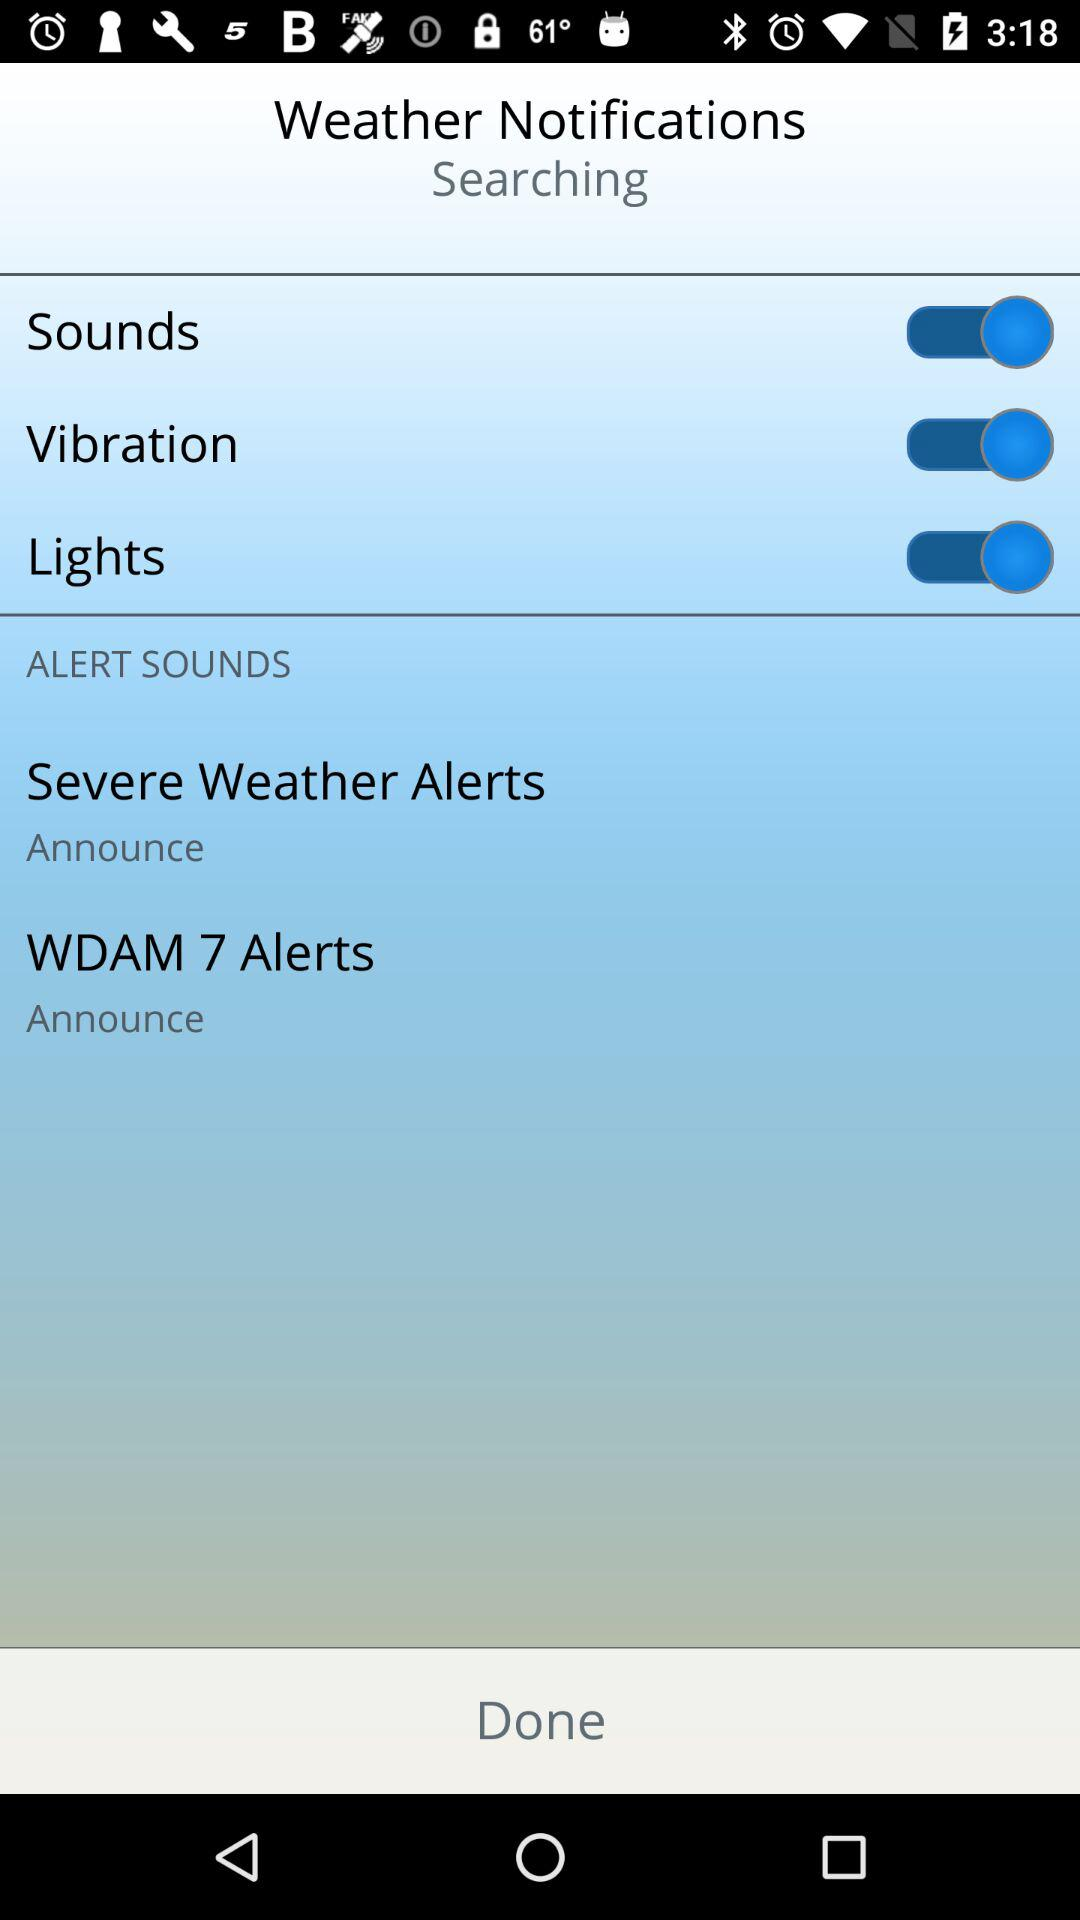How many WDAM were changed?
When the provided information is insufficient, respond with <no answer>. <no answer> 